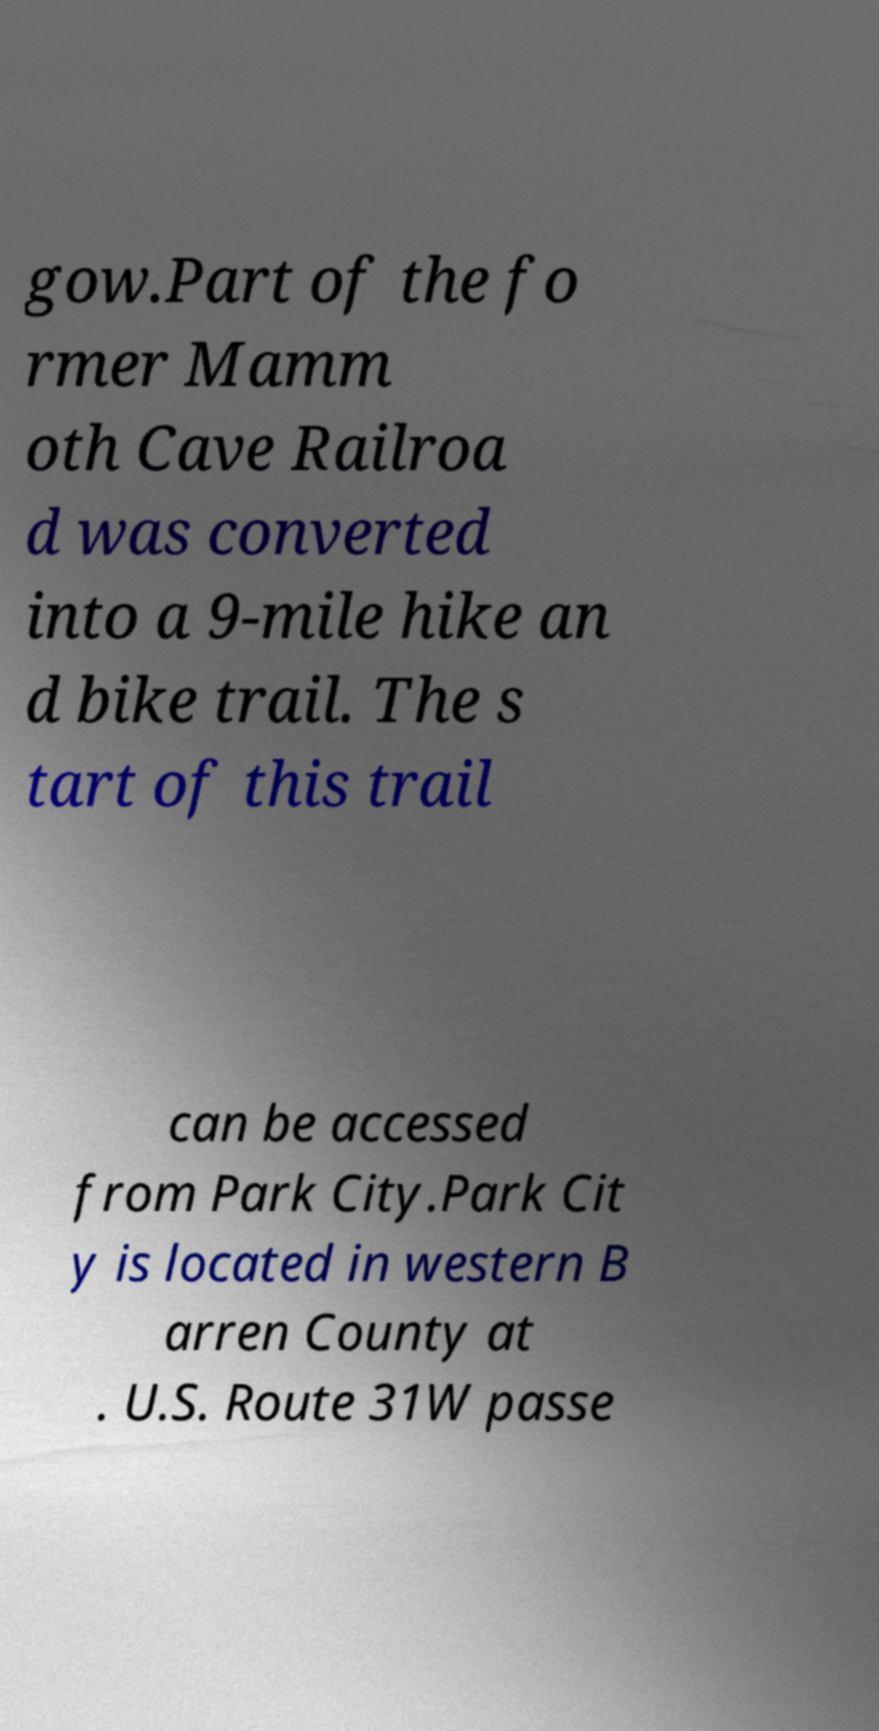Could you extract and type out the text from this image? gow.Part of the fo rmer Mamm oth Cave Railroa d was converted into a 9-mile hike an d bike trail. The s tart of this trail can be accessed from Park City.Park Cit y is located in western B arren County at . U.S. Route 31W passe 